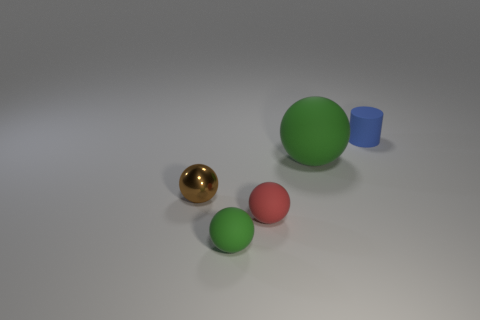Subtract all small balls. How many balls are left? 1 Subtract all green balls. How many balls are left? 2 Subtract 2 balls. How many balls are left? 2 Subtract all blue metallic spheres. Subtract all small brown shiny balls. How many objects are left? 4 Add 2 tiny blue rubber cylinders. How many tiny blue rubber cylinders are left? 3 Add 1 cyan things. How many cyan things exist? 1 Add 5 small matte blocks. How many objects exist? 10 Subtract 0 red cylinders. How many objects are left? 5 Subtract all spheres. How many objects are left? 1 Subtract all red balls. Subtract all gray cylinders. How many balls are left? 3 